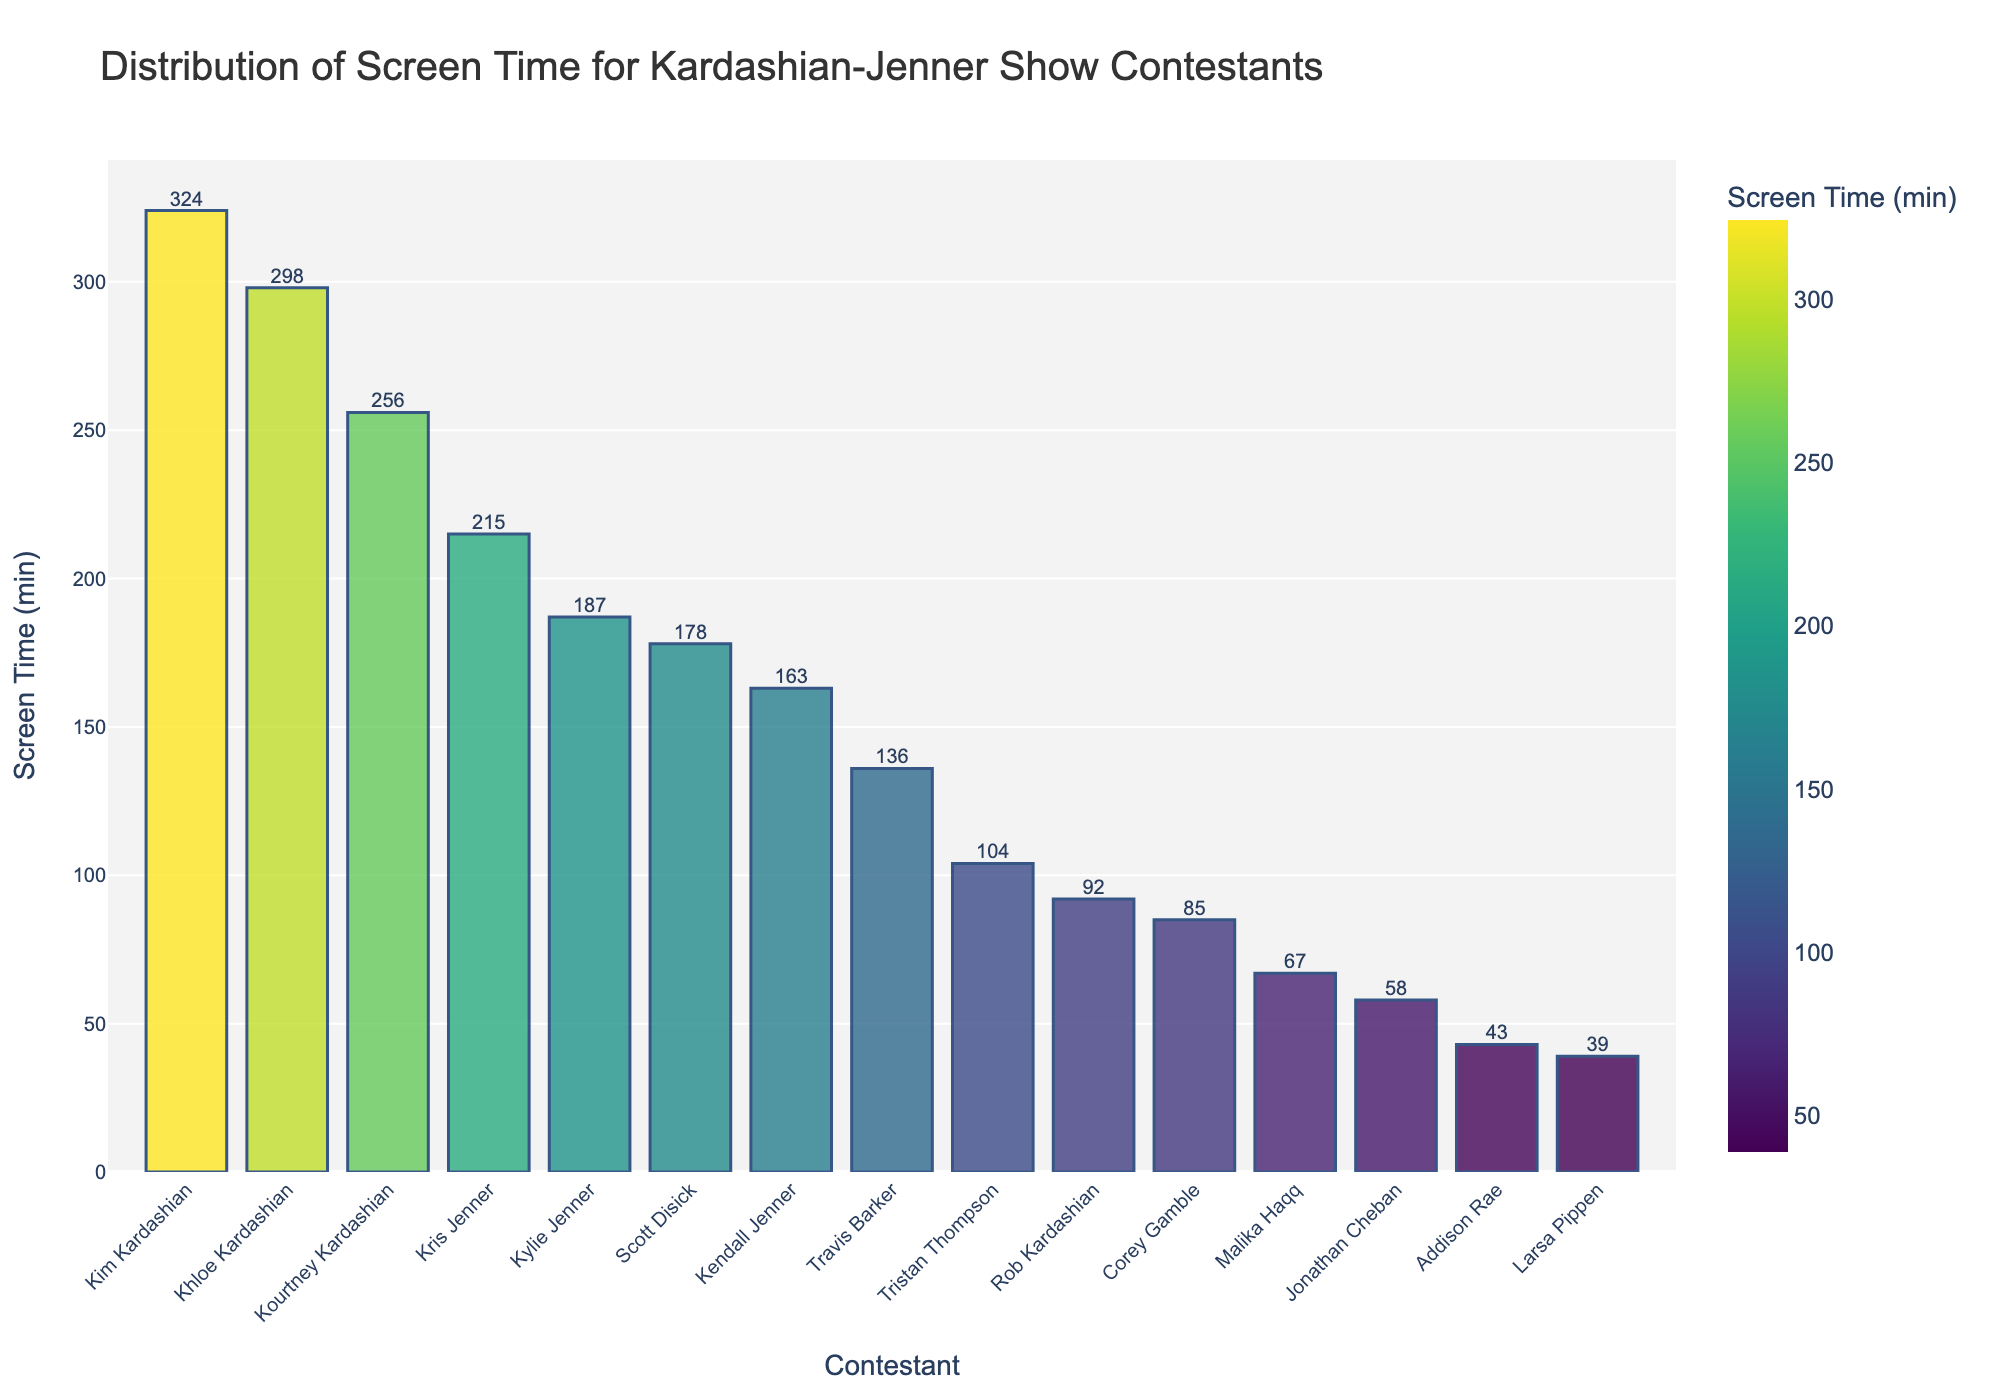Who has the most screen time? To determine the contestant with the most screen time, observe the height of the bars on the chart. The tallest bar represents the contestant with the highest screen time.
Answer: Kim Kardashian How much more screen time does Khloe have compared to Kendall? Identify the bars for Khloe and Kendall. Note their heights, which correspond to 298 minutes for Khloe and 163 minutes for Kendall. Subtract Kendall's screen time from Khloe's. 298 - 163 = 135
Answer: 135 minutes What is the total screen time of all the Jenner family members combined? Locate the screen times for each Jenner family member (Kris, Kylie, Kendall), which are 215, 187, and 163 minutes, respectively. Sum these values: 215 + 187 + 163 = 565
Answer: 565 minutes Which contestant has the least screen time, and how many minutes is it? Find the shortest bar to identify the contestant with the least screen time. The label and value at the top of this bar reveal the contestant and their screen time.
Answer: Larsa Pippen, 39 minutes Compare the screen times of Kris Jenner and Scott Disick. Who has more, and by how much? Identify the heights of the bars for Kris Jenner and Scott Disick, which are 215 and 178 minutes, respectively. Subtract Scott's screen time from Kris's to determine the difference. 215 - 178 = 37
Answer: Kris Jenner, 37 minutes What is the average screen time of all contestants? Sum the screen time of all contestants listed: 324 + 256 + 298 + 215 + 187 + 163 + 92 + 178 + 104 + 136 + 85 + 67 + 58 + 43 + 39 = 2245. Divide by the number of contestants (15) to find the average, 2245 / 15 ≈ 149.67
Answer: 149.67 minutes Who has more screen time, Kourtney Kardashian or Tristan Thompson? Compare the heights of the bars for Kourtney Kardashian and Tristan Thompson. Kourtney's bar is 256 minutes, while Tristan's is 104 minutes.
Answer: Kourtney Kardashian Which two contestants have the closest screen times? Identify bars with similar heights and compare their numeric values. Scott Disick (178) and Travis Barker (136) have a difference of 42 minutes, while Khloe Kardashian (298) and Kris Jenner (215) have a difference of 83 minutes.
Answer: Kris Jenner and Kourtney Kardashian What is the difference in screen time between the contestant with the most time and the one with the least? Identify the largest and smallest screen time values: Kim Kardashian with 324 minutes and Larsa Pippen with 39 minutes. Subtract the smallest value from the largest: 324 - 39 = 285
Answer: 285 minutes What is the median screen time value of all the contestants? List all screen times in ascending order: 39, 43, 58, 67, 85, 92, 104, 136, 163, 178, 187, 215, 256, 298, 324. The median is the middle value in this ordered list. Since there are 15 values, the median is the 8th one.
Answer: 136 minutes 